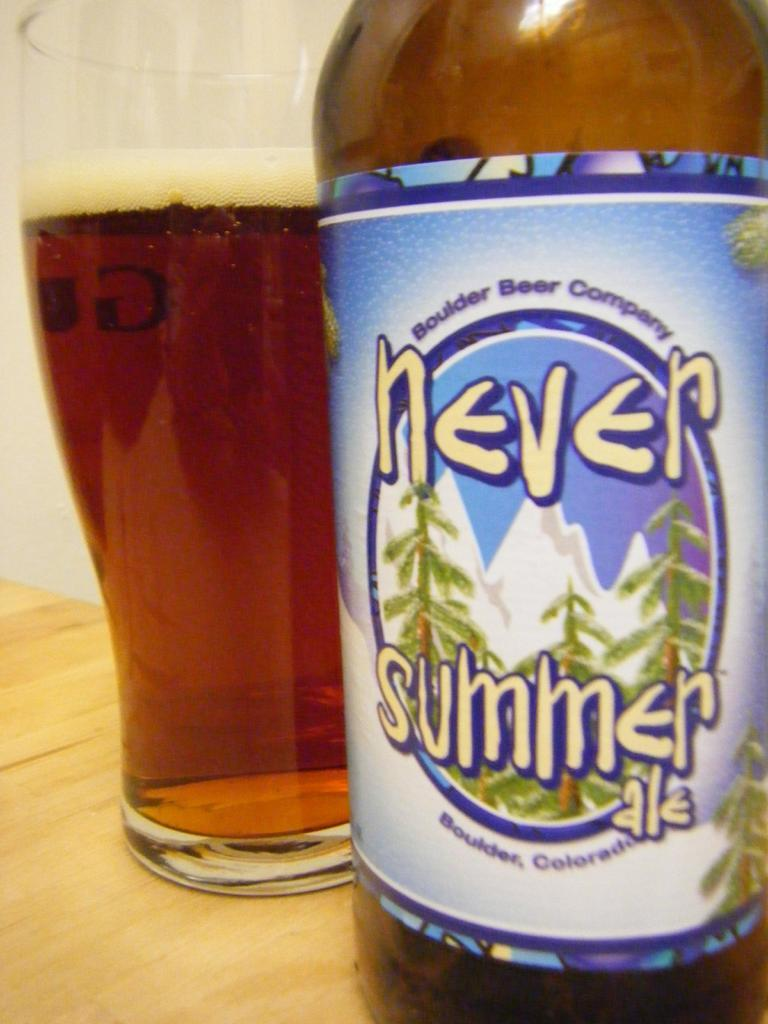Provide a one-sentence caption for the provided image. A pint glass of beer sits next to a bottle of Never Summer ale. 